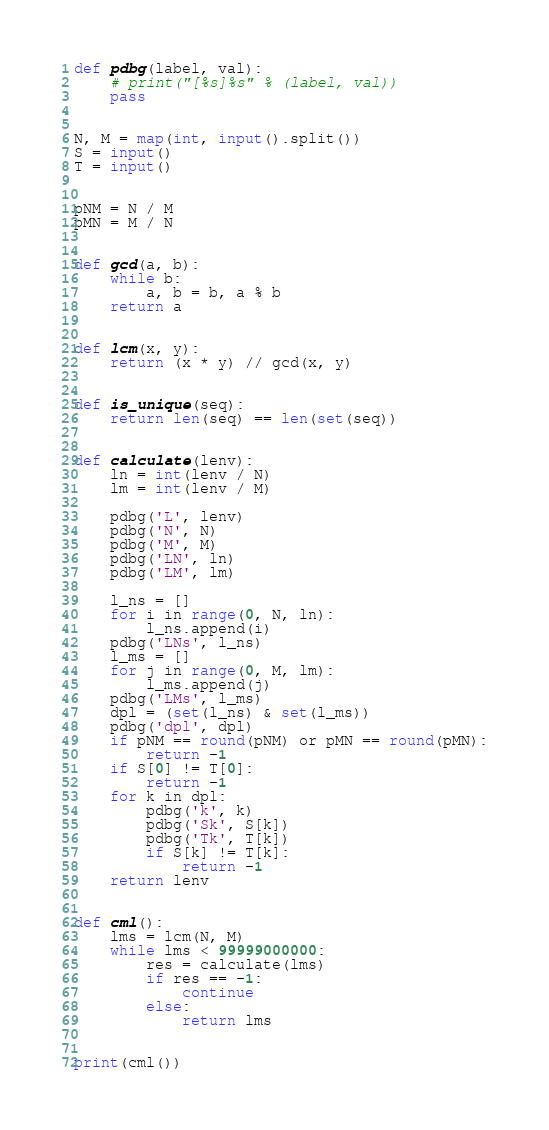<code> <loc_0><loc_0><loc_500><loc_500><_Python_>def pdbg(label, val):
    # print("[%s]%s" % (label, val))
    pass


N, M = map(int, input().split())
S = input()
T = input()


pNM = N / M
pMN = M / N


def gcd(a, b):
    while b:
        a, b = b, a % b
    return a


def lcm(x, y):
    return (x * y) // gcd(x, y)


def is_unique(seq):
    return len(seq) == len(set(seq))


def calculate(lenv):
    ln = int(lenv / N)
    lm = int(lenv / M)

    pdbg('L', lenv)
    pdbg('N', N)
    pdbg('M', M)
    pdbg('LN', ln)
    pdbg('LM', lm)

    l_ns = []
    for i in range(0, N, ln):
        l_ns.append(i)
    pdbg('LNs', l_ns)
    l_ms = []
    for j in range(0, M, lm):
        l_ms.append(j)
    pdbg('LMs', l_ms)
    dpl = (set(l_ns) & set(l_ms))
    pdbg('dpl', dpl)
    if pNM == round(pNM) or pMN == round(pMN):
        return -1
    if S[0] != T[0]:
        return -1
    for k in dpl:
        pdbg('k', k)
        pdbg('Sk', S[k])
        pdbg('Tk', T[k])
        if S[k] != T[k]:
            return -1
    return lenv


def cml():
    lms = lcm(N, M)
    while lms < 99999000000:
        res = calculate(lms)
        if res == -1:
            continue
        else:
            return lms


print(cml())
</code> 